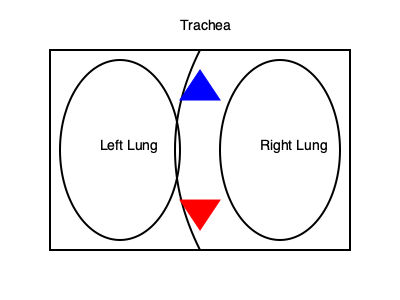In the diagram, which direction does the air flow during the inhalation phase of Pilates breathing, and how does this relate to the engagement of core muscles? To answer this question, let's break down the Pilates breathing technique and its relationship to the diagram:

1. Pilates Breathing Technique:
   - Pilates emphasizes lateral thoracic breathing, also known as "ribcage breathing."
   - This technique involves expanding the ribcage laterally during inhalation.

2. Inhalation Phase:
   - In the diagram, the blue triangle at the top represents inhalation.
   - The air flows downward and outward into the lungs.
   - This is indicated by the blue triangle pointing downward into the lungs.

3. Lung Expansion:
   - During inhalation, the lungs expand laterally and slightly downward.
   - This expansion is resisted by the engaged core muscles.

4. Core Engagement:
   - In Pilates, practitioners maintain a slight engagement of the deep abdominal muscles throughout the breath cycle.
   - This engagement provides resistance to the expanding lungs, creating a balance between the breath and core stability.

5. Relationship to Core Muscles:
   - The downward and outward flow of air during inhalation creates a natural tendency for the abdominal wall to protrude.
   - However, the engaged core muscles resist this outward movement, maintaining stability of the trunk.
   - This resistance helps to strengthen the deep abdominal muscles and improve overall core control.

6. Benefits:
   - This breathing technique, combined with core engagement, enhances oxygen intake while maintaining core stability.
   - It supports proper posture and alignment during Pilates exercises.

Therefore, during the inhalation phase of Pilates breathing, the air flows downward and outward into the lungs, while the engaged core muscles provide resistance to maintain stability.
Answer: Downward and outward; core muscles resist expansion, maintaining stability. 